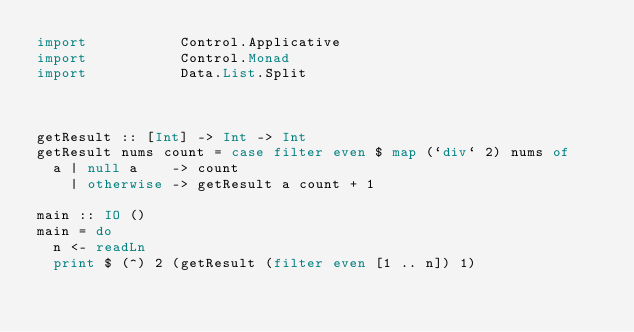Convert code to text. <code><loc_0><loc_0><loc_500><loc_500><_Haskell_>import           Control.Applicative
import           Control.Monad
import           Data.List.Split



getResult :: [Int] -> Int -> Int
getResult nums count = case filter even $ map (`div` 2) nums of
  a | null a    -> count
    | otherwise -> getResult a count + 1

main :: IO ()
main = do
  n <- readLn
  print $ (^) 2 (getResult (filter even [1 .. n]) 1)</code> 